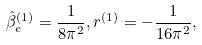<formula> <loc_0><loc_0><loc_500><loc_500>\hat { \beta } _ { e } ^ { ( 1 ) } = \frac { 1 } { 8 \pi ^ { 2 } } , r ^ { ( 1 ) } = - \frac { 1 } { 1 6 \pi ^ { 2 } } ,</formula> 